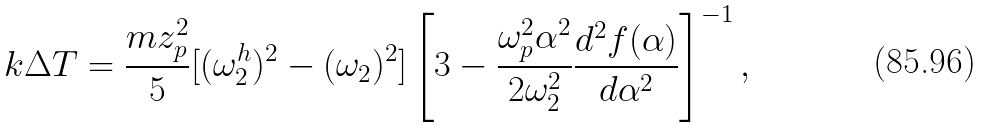Convert formula to latex. <formula><loc_0><loc_0><loc_500><loc_500>k \Delta T = \frac { m z _ { p } ^ { 2 } } { 5 } [ ( \omega _ { 2 } ^ { h } ) ^ { 2 } - ( \omega _ { 2 } ) ^ { 2 } ] \left [ 3 - \frac { \omega _ { p } ^ { 2 } \alpha ^ { 2 } } { 2 \omega _ { 2 } ^ { 2 } } \frac { d ^ { 2 } f ( \alpha ) } { d \alpha ^ { 2 } } \right ] ^ { - 1 } ,</formula> 